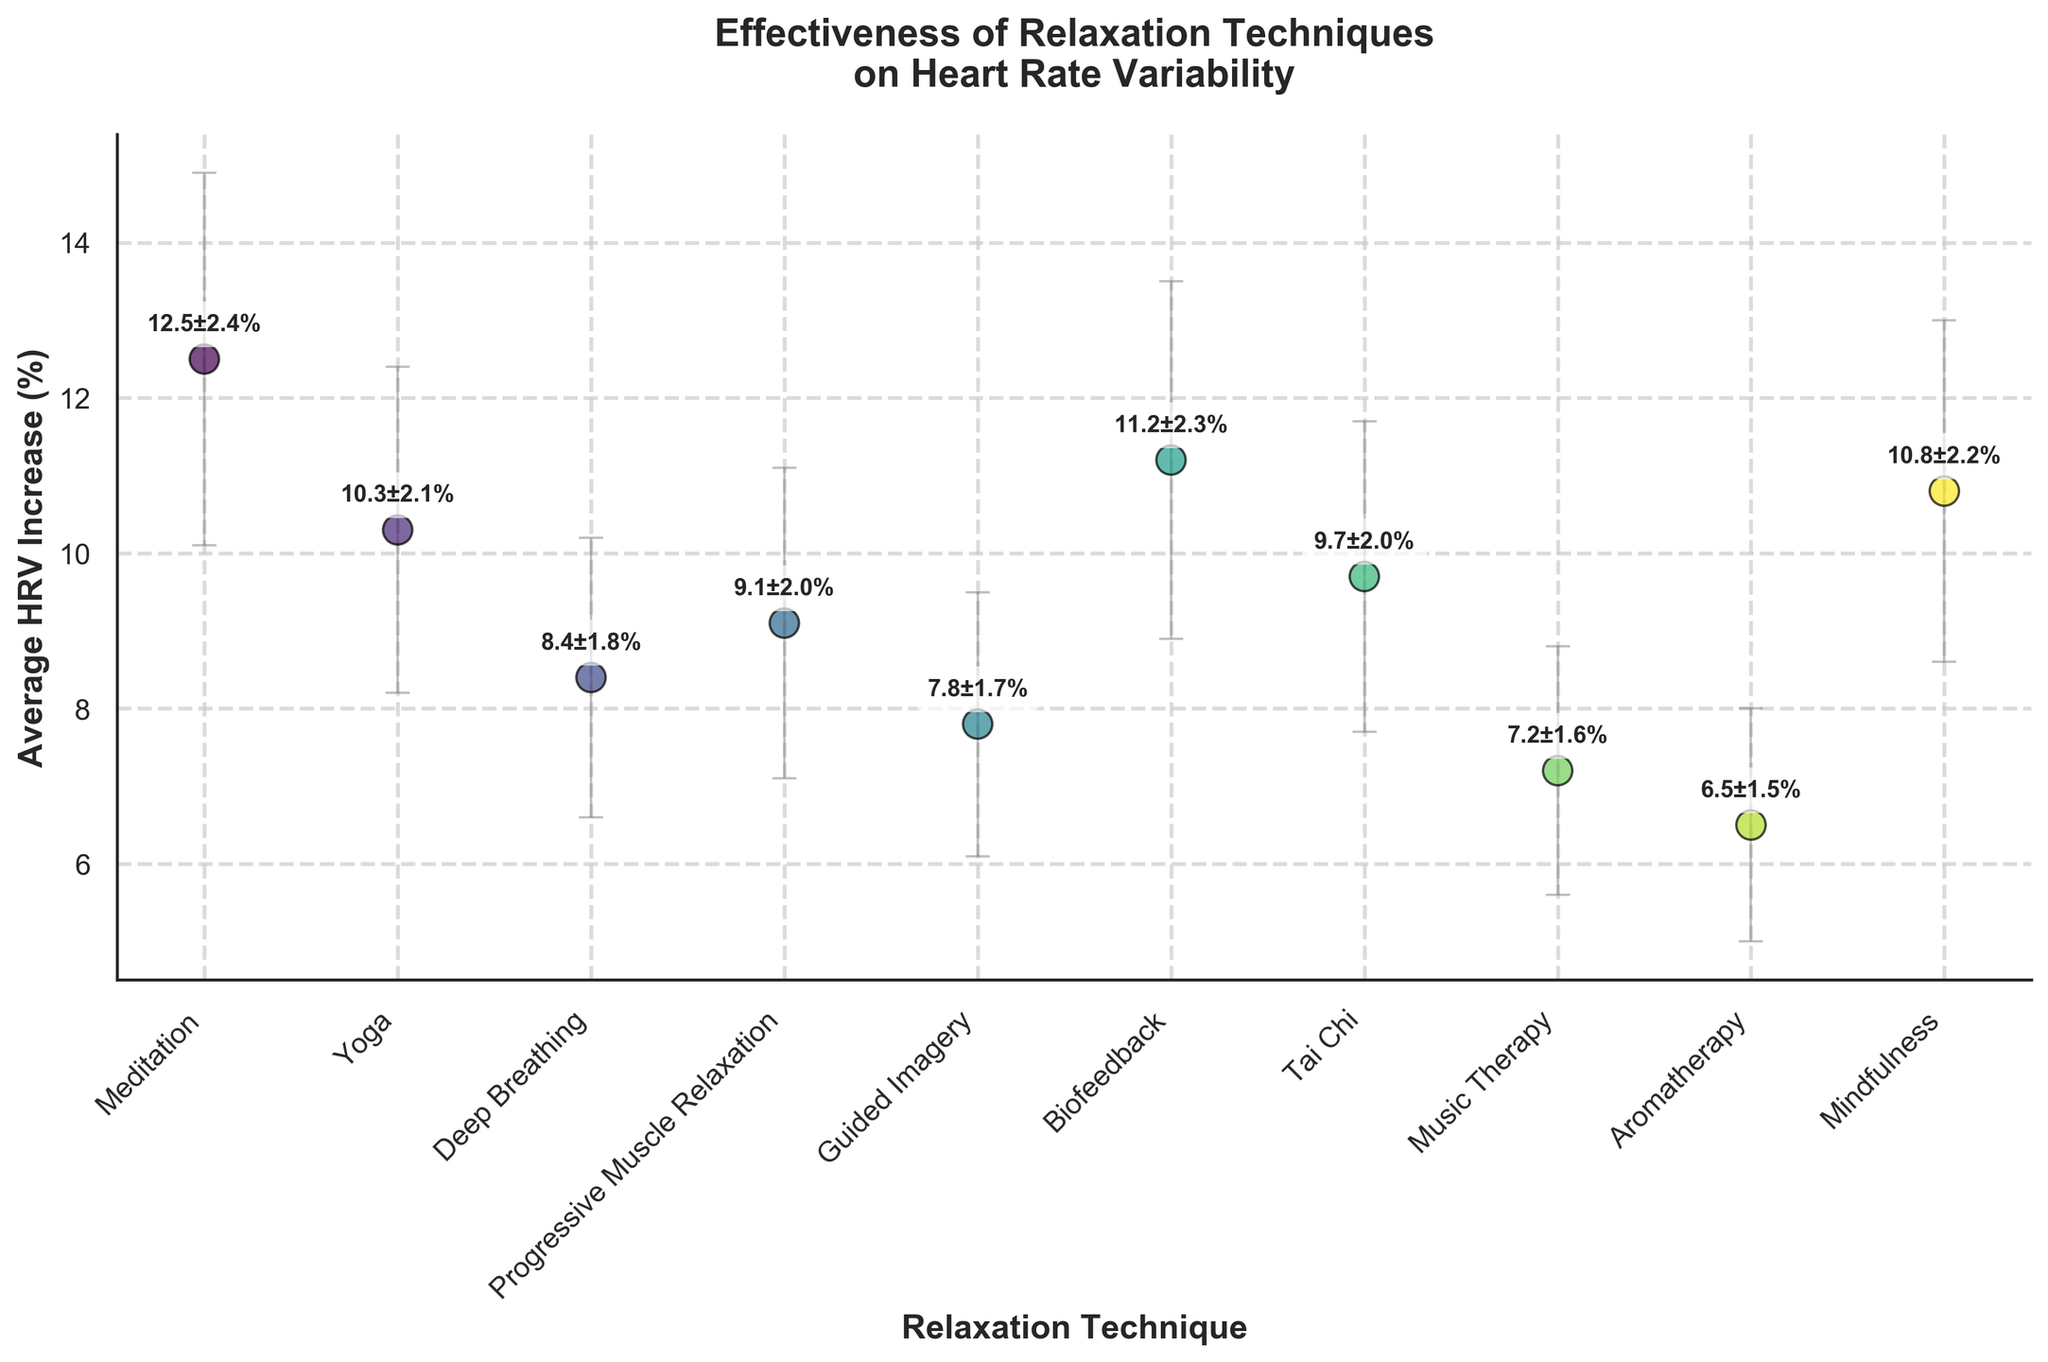What's the title of the plot? The title is located at the top of the figure and uses larger, bold font to stand out. It reads "Effectiveness of Relaxation Techniques on Heart Rate Variability".
Answer: Effectiveness of Relaxation Techniques on Heart Rate Variability Which relaxation technique has the highest average HRV increase? By looking at the scatter plot, the data point with the highest y-coordinate value represents the highest HRV increase. The point labeled "Meditation" has the highest value.
Answer: Meditation What is the average HRV increase for Mindfulness? The annotation next to the data point labeled "Mindfulness" provides the HRV increase value. It's shown as "10.8%".
Answer: 10.8% Which technique shows the smallest error margin in HRV increase? The smallest error bar, which indicates the error margin, can be visually inspected. The point labeled "Aromatherapy" has the smallest error bar.
Answer: Aromatherapy How many relaxation techniques are represented in the plot? By counting the distinct data points on the x-axis, we can see there are 10 different techniques listed.
Answer: 10 Compare the HRV increase between Yoga and Guided Imagery. Which one is higher and by how much? By looking at their respective positions on the y-axis and their annotations, Yoga has a value of 10.3% and Guided Imagery has a value of 7.8%. The difference is 10.3% - 7.8% = 2.5%.
Answer: Yoga, 2.5% What's the average HRV increase for all techniques combined? The average can be calculated by summing all the HRV increase values and dividing by the number of techniques. Adding the values (12.5 + 10.3 + 8.4 + 9.1 + 7.8 + 11.2 + 9.7 + 7.2 + 6.5 + 10.8) gives 93.5. Dividing by 10 gives an average of 9.35%.
Answer: 9.35% Which technique has the annotations showing the smallest increase and error margin combined? By looking closely at the smallest combined value of HRV increase and error margin, Aromatherapy (6.5 ± 1.5%) shows the smallest sum when including its error margin (6.5 + 1.5 = 8.0).
Answer: Aromatherapy If we group techniques with HRV increases above 10% as "High Effectiveness" and the rest as "Moderate Effectiveness", how many techniques fall into each category? The techniques above 10% are Meditation, Yoga, Biofeedback, Mindfulness. Four techniques are above 10%. The rest are below or equal to 10%, giving us 6 techniques in the "Moderate Effectiveness" category.
Answer: 4 High Effectiveness, 6 Moderate Effectiveness 